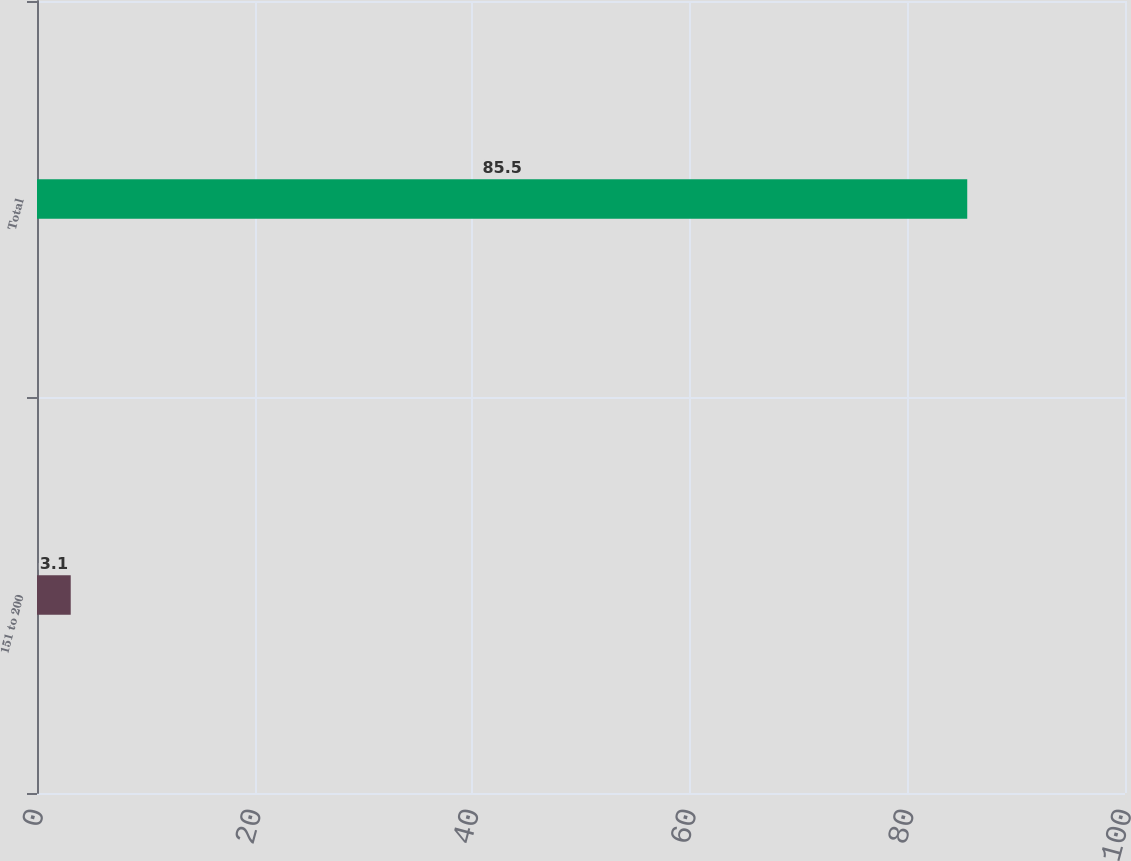Convert chart to OTSL. <chart><loc_0><loc_0><loc_500><loc_500><bar_chart><fcel>151 to 200<fcel>Total<nl><fcel>3.1<fcel>85.5<nl></chart> 